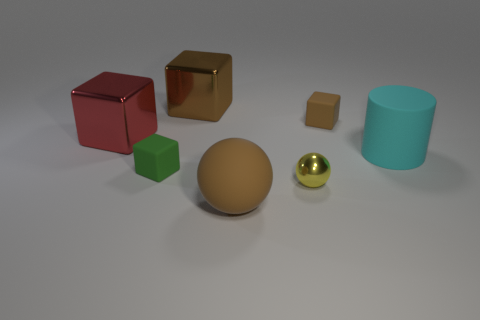Subtract all small green rubber blocks. How many blocks are left? 3 Subtract all purple cylinders. How many brown blocks are left? 2 Add 3 blue balls. How many objects exist? 10 Subtract all green blocks. How many blocks are left? 3 Subtract 2 cubes. How many cubes are left? 2 Subtract all cylinders. How many objects are left? 6 Add 3 cyan cylinders. How many cyan cylinders exist? 4 Subtract 1 green cubes. How many objects are left? 6 Subtract all gray spheres. Subtract all blue blocks. How many spheres are left? 2 Subtract all metallic spheres. Subtract all balls. How many objects are left? 4 